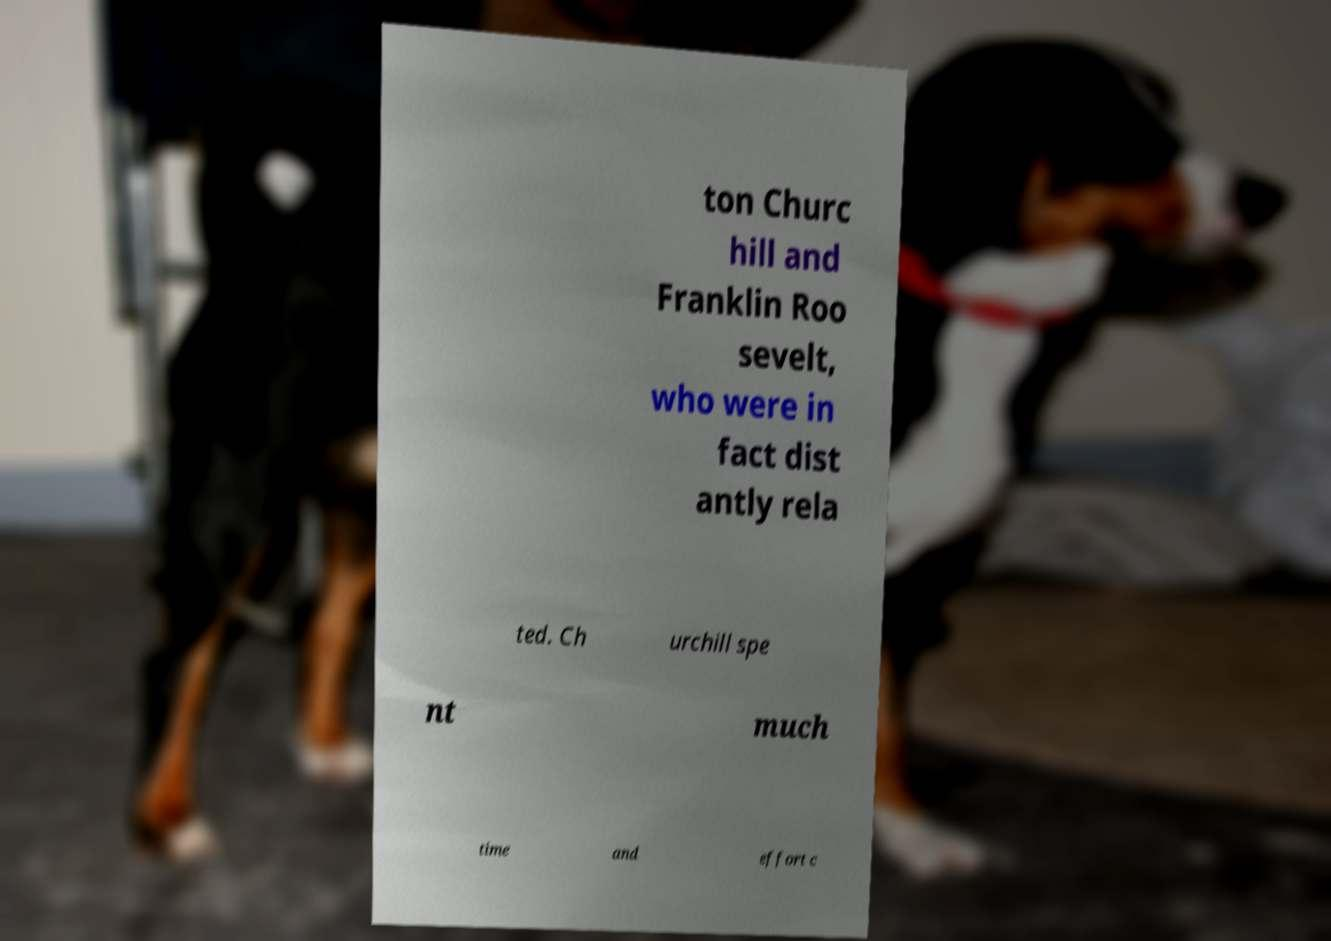For documentation purposes, I need the text within this image transcribed. Could you provide that? ton Churc hill and Franklin Roo sevelt, who were in fact dist antly rela ted. Ch urchill spe nt much time and effort c 